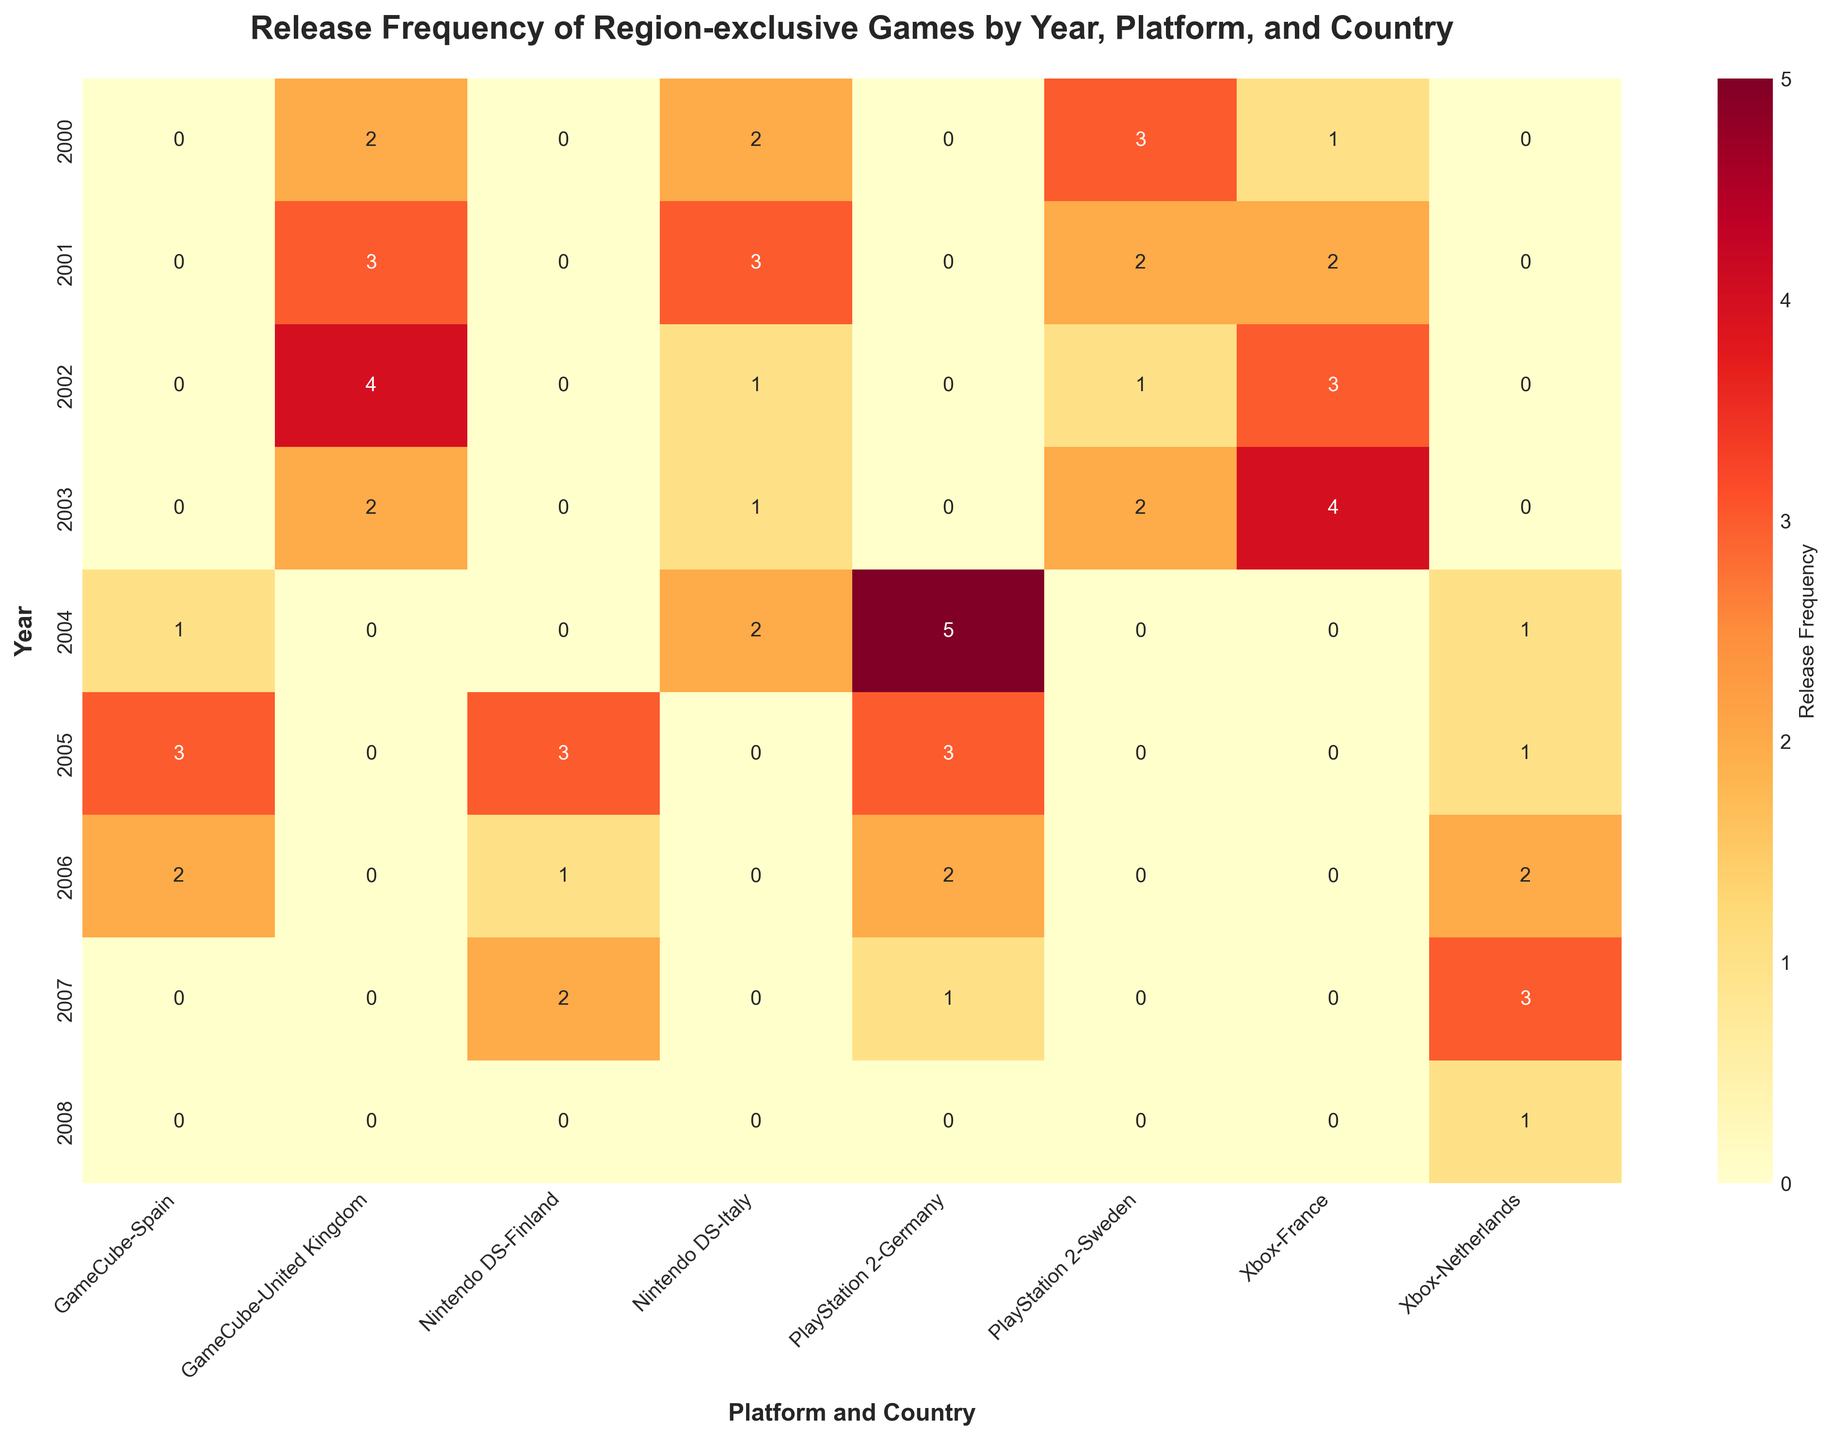What is the title of the heatmap? The title is usually placed at the top of the figure in larger, bold text.
Answer: Release Frequency of Region-exclusive Games by Year, Platform, and Country In which country were the most region-exclusive PlayStation 2 games released in 2004? Look at the intersection of 2004, PlayStation 2, and the countries labeled on the x-axis. The highest number will indicate the country.
Answer: Germany Which year had the highest number of releases for GameCube games in the United Kingdom? Identify the row corresponding to the United Kingdom under the GameCube column and pick the highest value.
Answer: 2002 How did the release frequency for Xbox games in the Netherlands change from 2007 to 2008? Look at the values for Xbox in the Netherlands in both 2007 and 2008, then calculate the change.
Answer: Decreased by 2 (from 3 to 1) Which platform had the most consistent release frequency in Sweden from 2000 to 2003? Check the values for each platform in Sweden from 2000 to 2003. Consistency means the values are similar for each year.
Answer: PlayStation 2 How does the release frequency for Nintendo DS games in Italy in 2003 compare to 2002? Look at the release frequency values for the Nintendo DS in Italy for the years 2002 and 2003 and compare them.
Answer: Same (1) Which platform had the peak release frequency in Germany, and in what year did it occur? Look at the values under Germany for all platforms to find the highest number and note the year.
Answer: PlayStation 2, 2004 What is the total number of releases for GameCube games in Spain from 2004 to 2006? Sum the release frequencies for GameCube in Spain for the years 2004, 2005, and 2006.
Answer: 6 Which country saw an increase in release frequency for Nintendo DS games from 2006 to 2007? Check the values for Nintendo DS in all countries for the years 2006 and 2007 to find an increase.
Answer: Finland What is the average release frequency of Xbox games in France from 2000 to 2003? Sum the release frequencies for Xbox in France for these years and then divide by the number of years (4). The total is (1 + 2 + 3 + 4 = 10); average is 10/4 = 2.5
Answer: 2.5 